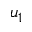Convert formula to latex. <formula><loc_0><loc_0><loc_500><loc_500>u _ { 1 }</formula> 